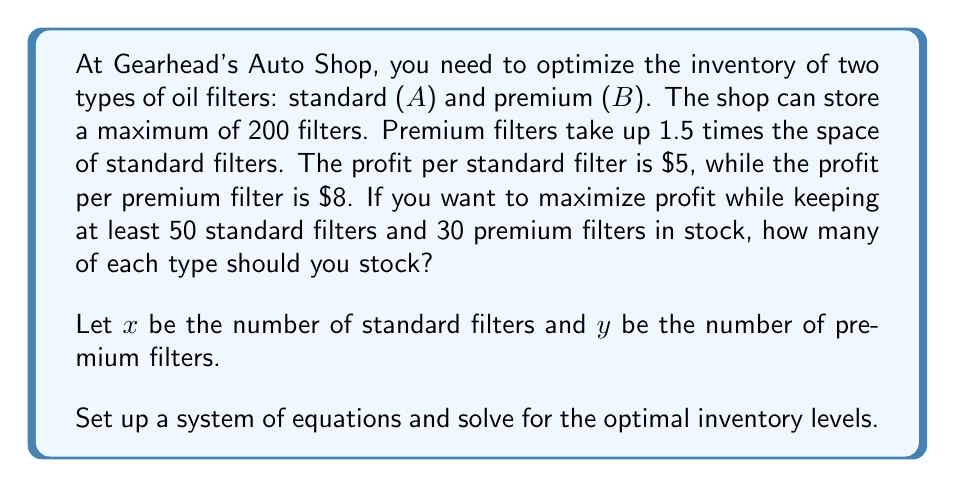Help me with this question. Let's approach this step-by-step:

1) First, we need to set up our constraints:

   a) Space constraint: $x + 1.5y \leq 200$
   b) Minimum stock for standard filters: $x \geq 50$
   c) Minimum stock for premium filters: $y \geq 30$

2) Our objective function (profit) is: $P = 5x + 8y$

3) We can visualize this as a linear programming problem. The feasible region is bounded by these constraints.

4) The optimal solution will be at one of the corner points of this feasible region.

5) To find these points, we solve the system of equations:

   $x + 1.5y = 200$
   $x = 50$
   $y = 30$

6) Solving these equations gives us three corner points:
   (50, 100), (50, 30), and (140, 40)

7) Let's evaluate the profit at each point:

   $P(50, 100) = 5(50) + 8(100) = 1050$
   $P(50, 30) = 5(50) + 8(30) = 490$
   $P(140, 40) = 5(140) + 8(40) = 1020$

8) The maximum profit occurs at the point (50, 100).

Therefore, to maximize profit, you should stock 50 standard filters and 100 premium filters.
Answer: 50 standard filters, 100 premium filters 